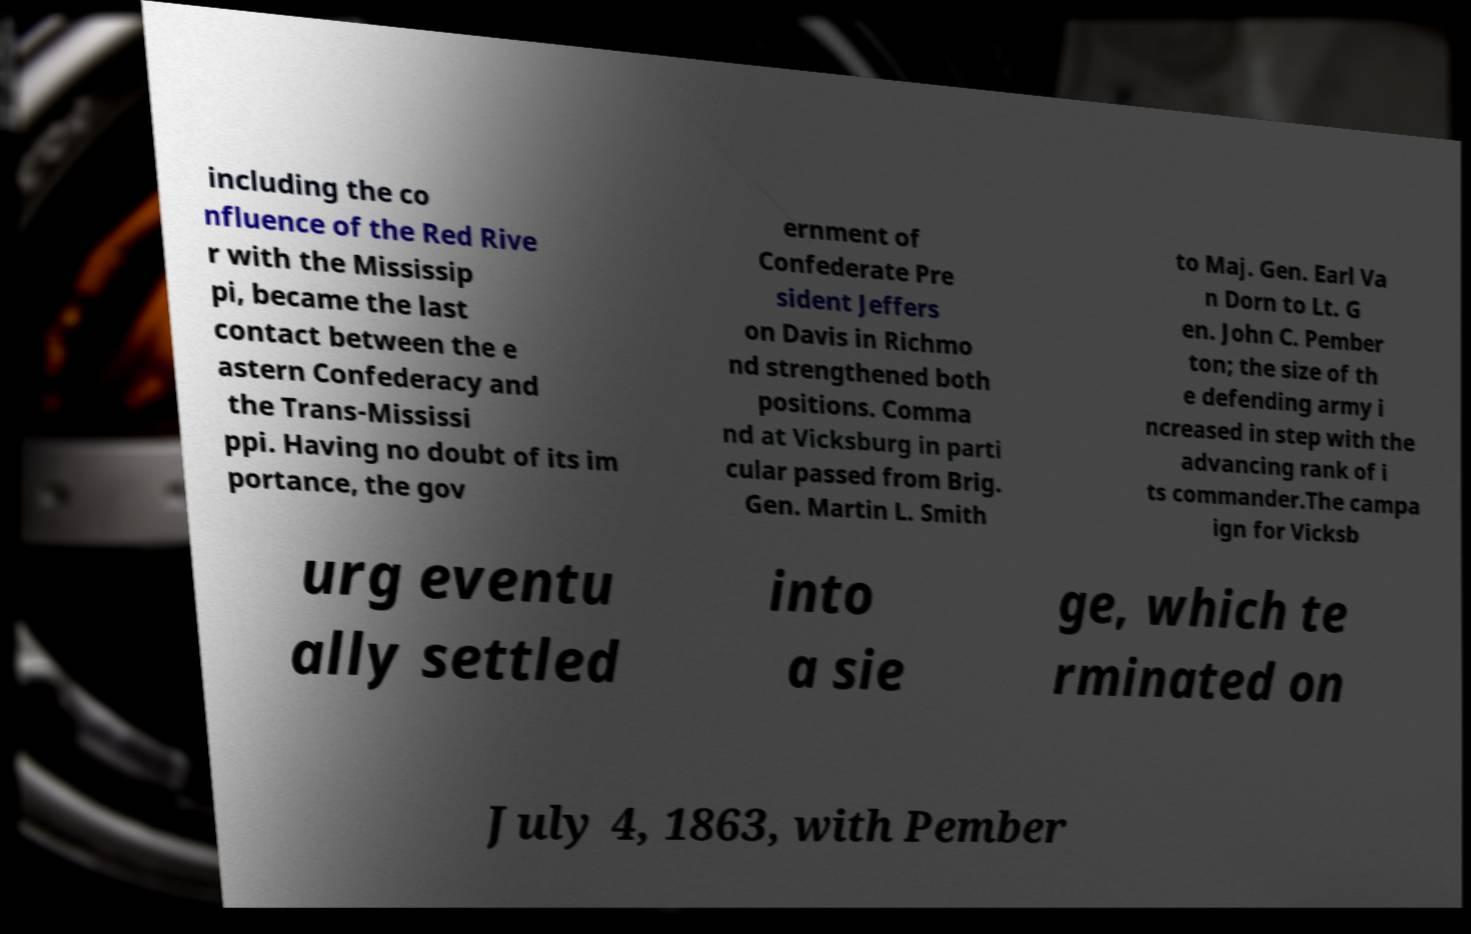What messages or text are displayed in this image? I need them in a readable, typed format. including the co nfluence of the Red Rive r with the Mississip pi, became the last contact between the e astern Confederacy and the Trans-Mississi ppi. Having no doubt of its im portance, the gov ernment of Confederate Pre sident Jeffers on Davis in Richmo nd strengthened both positions. Comma nd at Vicksburg in parti cular passed from Brig. Gen. Martin L. Smith to Maj. Gen. Earl Va n Dorn to Lt. G en. John C. Pember ton; the size of th e defending army i ncreased in step with the advancing rank of i ts commander.The campa ign for Vicksb urg eventu ally settled into a sie ge, which te rminated on July 4, 1863, with Pember 